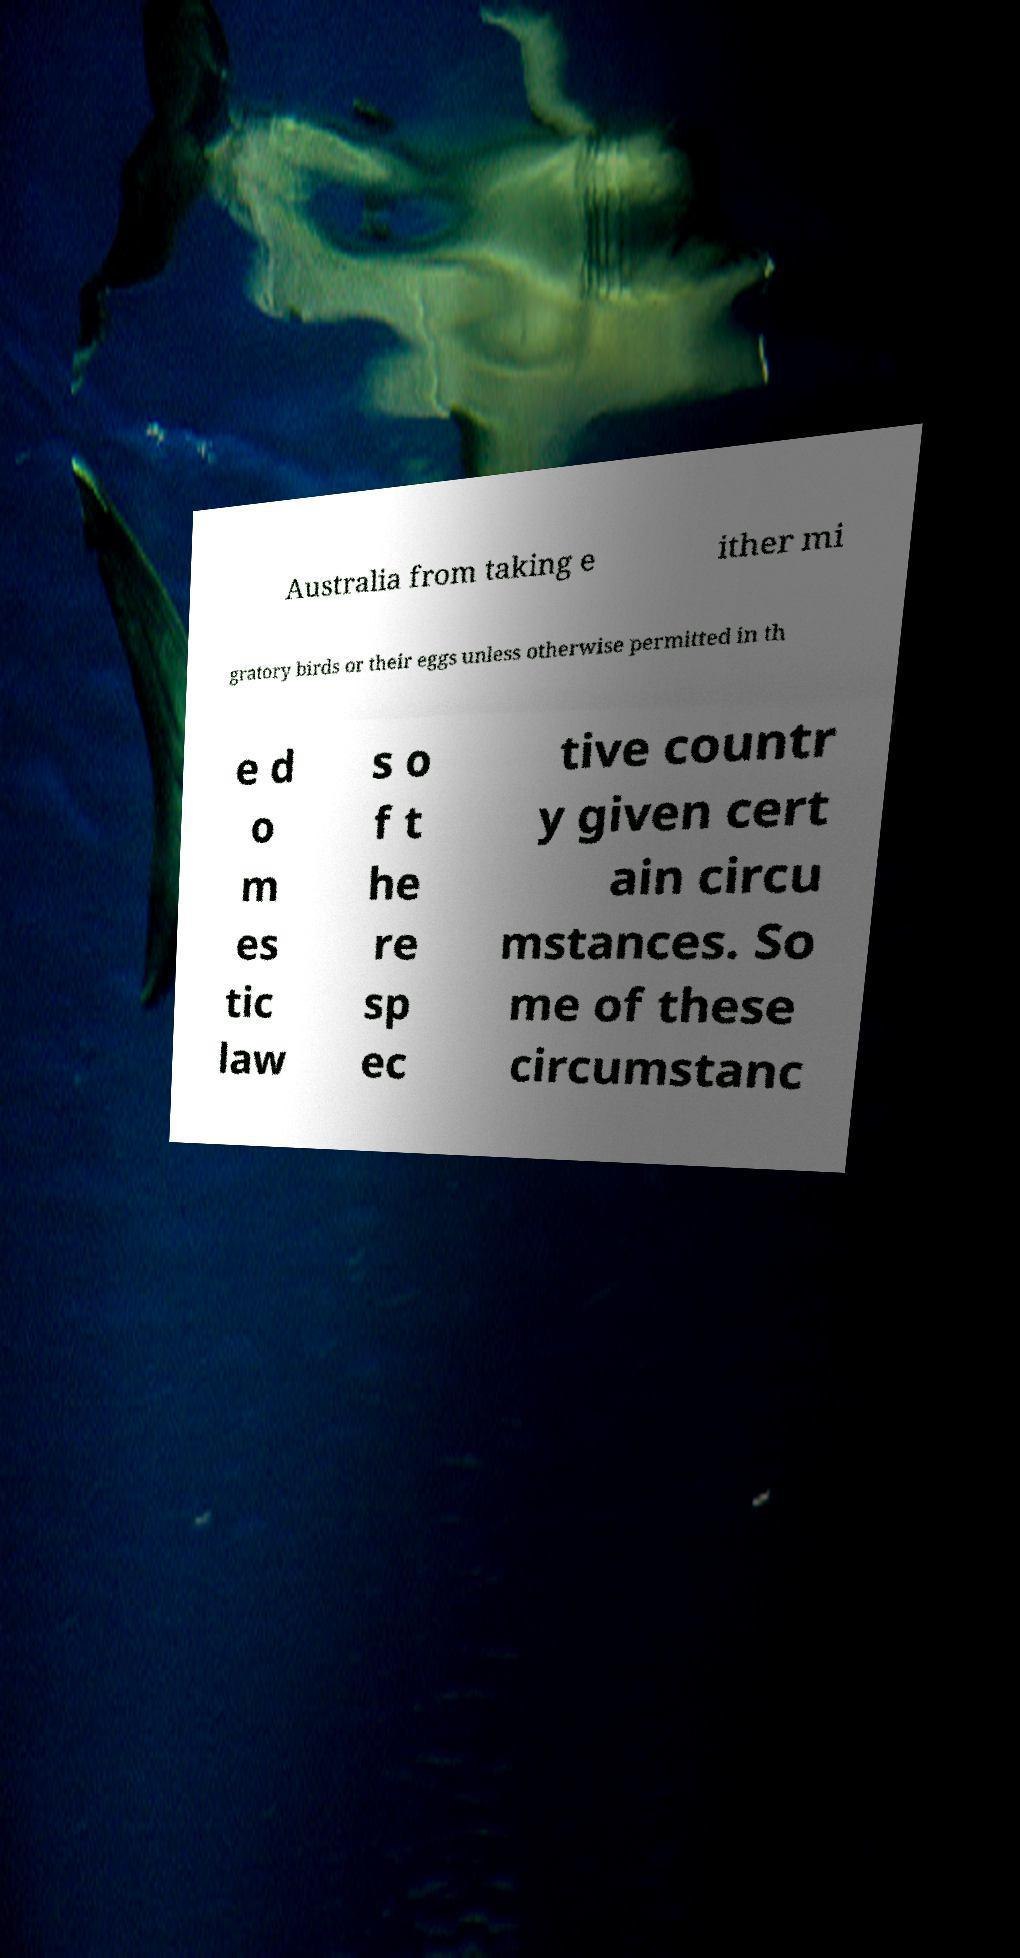Please read and relay the text visible in this image. What does it say? Australia from taking e ither mi gratory birds or their eggs unless otherwise permitted in th e d o m es tic law s o f t he re sp ec tive countr y given cert ain circu mstances. So me of these circumstanc 